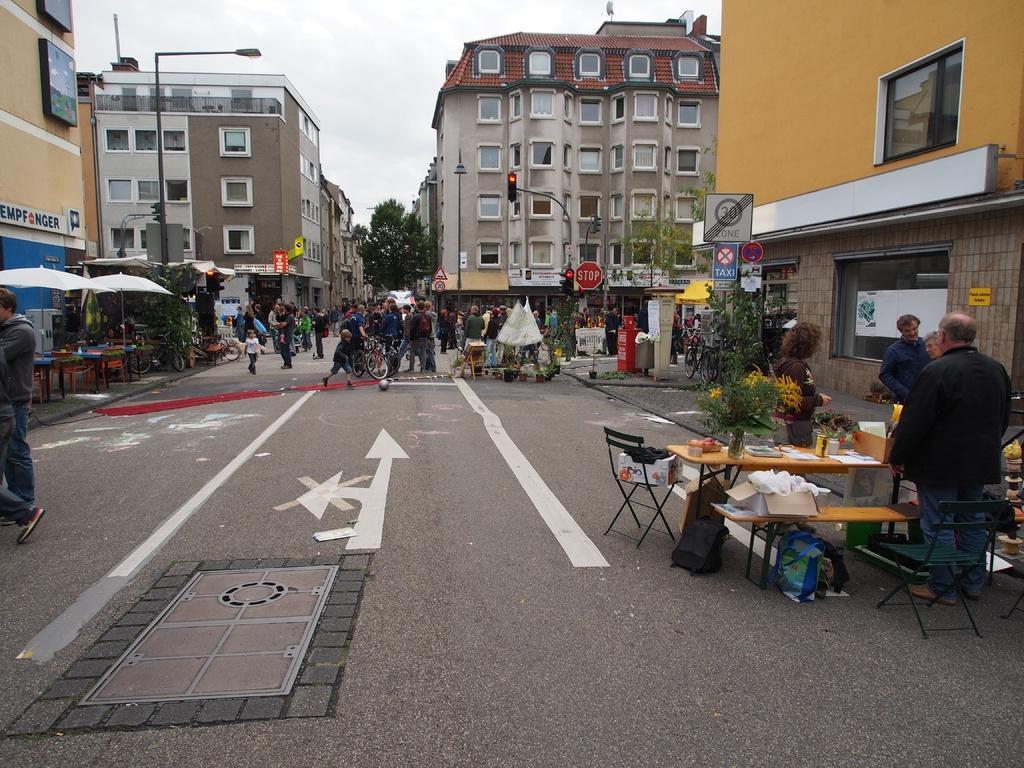Please provide a concise description of this image. This picture is clicked outside. On the right we can see the tables, benches and chairs and many number of items and we can see the group of people standing on ground. In the center we can see the group of people seems to be walking on the ground and there are some objects placed on the ground and we can see the white color umbrellas, boards, traffic light, poles, street light, buildings, trees and the sky. 